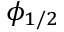Convert formula to latex. <formula><loc_0><loc_0><loc_500><loc_500>\phi _ { 1 / 2 }</formula> 